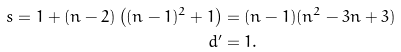Convert formula to latex. <formula><loc_0><loc_0><loc_500><loc_500>s = 1 + ( n - 2 ) \left ( ( n - 1 ) ^ { 2 } + 1 \right ) & = ( n - 1 ) ( n ^ { 2 } - 3 n + 3 ) \\ d ^ { \prime } & = 1 .</formula> 